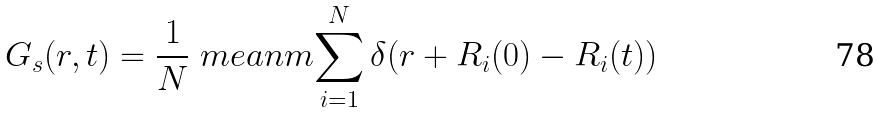<formula> <loc_0><loc_0><loc_500><loc_500>G _ { s } ( r , t ) = \frac { 1 } { N } \ m e a n m { \sum _ { i = 1 } ^ { N } \delta ( { r } + { R } _ { i } ( 0 ) - { R } _ { i } ( t ) ) }</formula> 